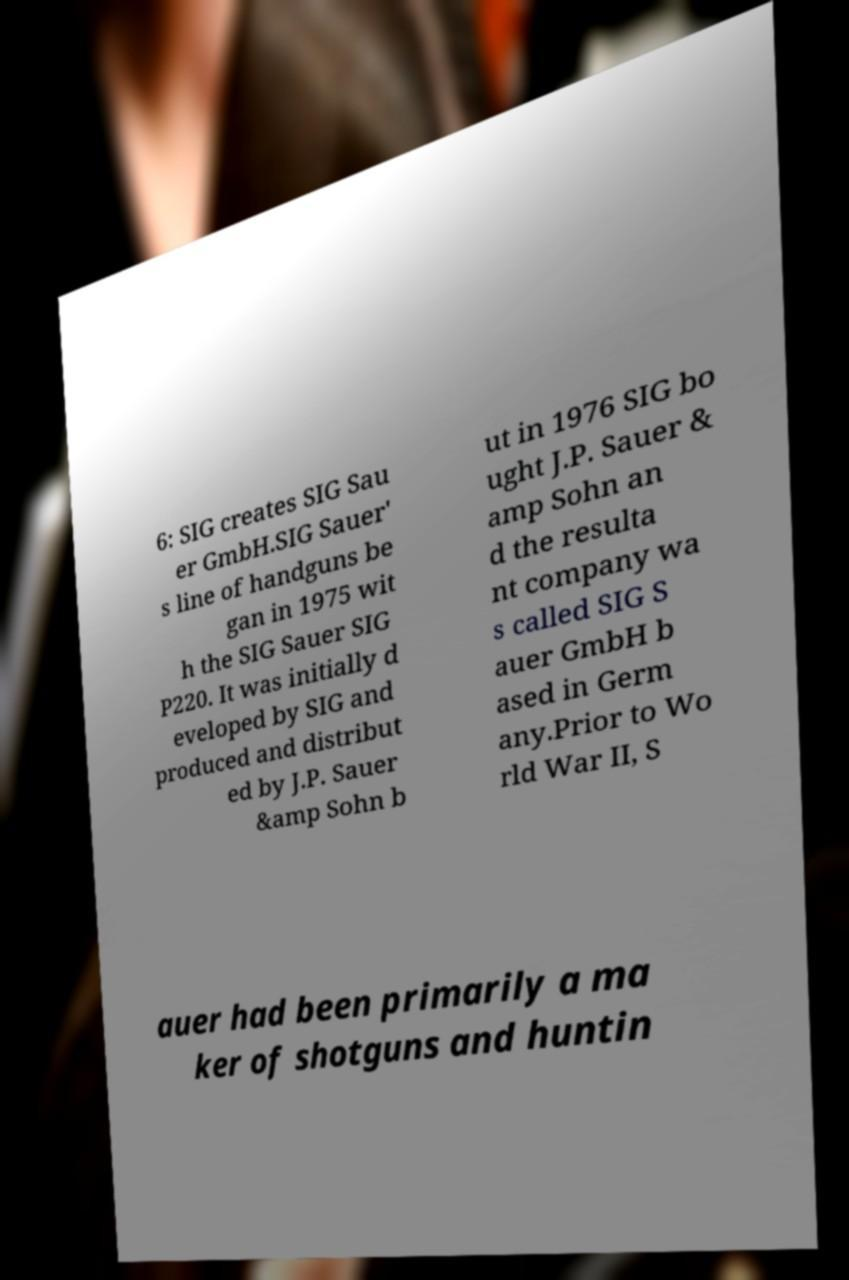Could you assist in decoding the text presented in this image and type it out clearly? 6: SIG creates SIG Sau er GmbH.SIG Sauer' s line of handguns be gan in 1975 wit h the SIG Sauer SIG P220. It was initially d eveloped by SIG and produced and distribut ed by J.P. Sauer &amp Sohn b ut in 1976 SIG bo ught J.P. Sauer & amp Sohn an d the resulta nt company wa s called SIG S auer GmbH b ased in Germ any.Prior to Wo rld War II, S auer had been primarily a ma ker of shotguns and huntin 